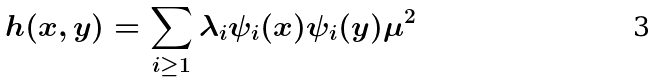<formula> <loc_0><loc_0><loc_500><loc_500>h ( x , y ) = \sum _ { i \geq 1 } \lambda _ { i } \psi _ { i } ( x ) \psi _ { i } ( y ) \mu ^ { 2 }</formula> 